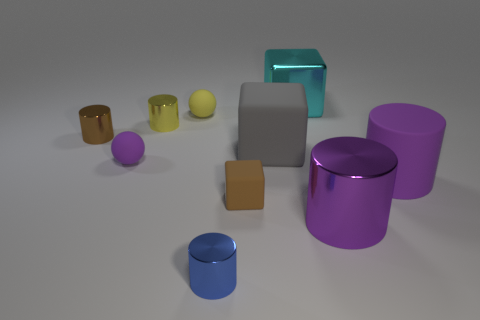Is the color of the matte cylinder the same as the big metallic cylinder?
Provide a short and direct response. Yes. The brown thing that is the same material as the tiny yellow ball is what shape?
Provide a short and direct response. Cube. How many yellow things are the same shape as the small blue metal thing?
Provide a short and direct response. 1. The large shiny thing that is in front of the brown object in front of the big gray rubber thing is what shape?
Keep it short and to the point. Cylinder. There is a purple cylinder that is behind the brown matte thing; is it the same size as the tiny purple rubber object?
Your answer should be compact. No. There is a metallic cylinder that is behind the rubber cylinder and in front of the yellow cylinder; what is its size?
Your answer should be very brief. Small. What number of yellow rubber things are the same size as the blue shiny cylinder?
Provide a short and direct response. 1. There is a yellow rubber ball that is behind the small cube; what number of matte balls are on the left side of it?
Keep it short and to the point. 1. There is a large rubber thing that is to the right of the gray rubber thing; is it the same color as the big shiny cylinder?
Give a very brief answer. Yes. There is a small object that is in front of the big purple object that is to the left of the big purple rubber thing; is there a gray block on the left side of it?
Make the answer very short. No. 